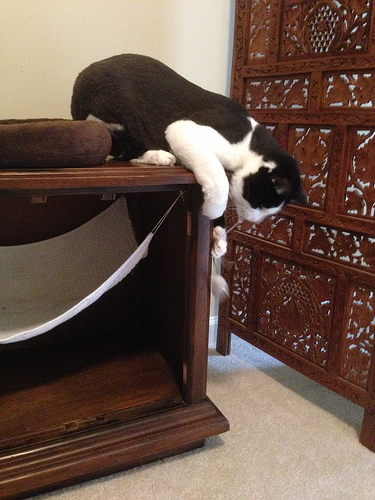<image>
Is the cat on the table? Yes. Looking at the image, I can see the cat is positioned on top of the table, with the table providing support. 